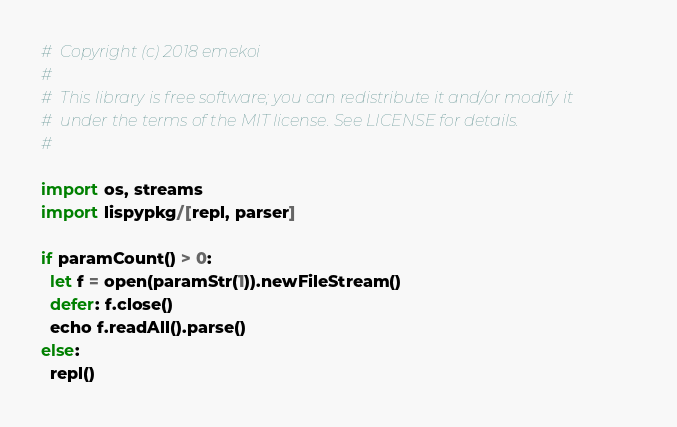<code> <loc_0><loc_0><loc_500><loc_500><_Nim_>#  Copyright (c) 2018 emekoi
#
#  This library is free software; you can redistribute it and/or modify it
#  under the terms of the MIT license. See LICENSE for details.
#

import os, streams
import lispypkg/[repl, parser]

if paramCount() > 0:
  let f = open(paramStr(1)).newFileStream()
  defer: f.close()
  echo f.readAll().parse()
else:
  repl()
</code> 